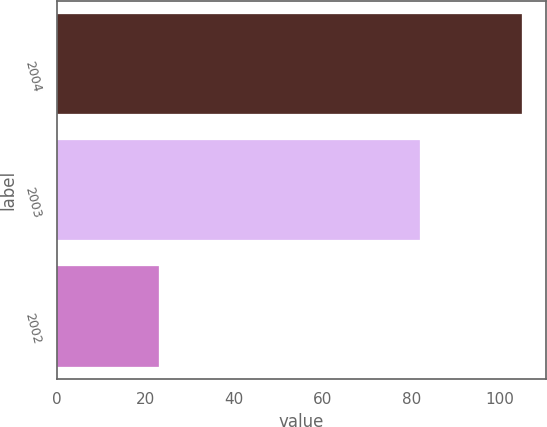Convert chart to OTSL. <chart><loc_0><loc_0><loc_500><loc_500><bar_chart><fcel>2004<fcel>2003<fcel>2002<nl><fcel>105<fcel>82<fcel>23<nl></chart> 